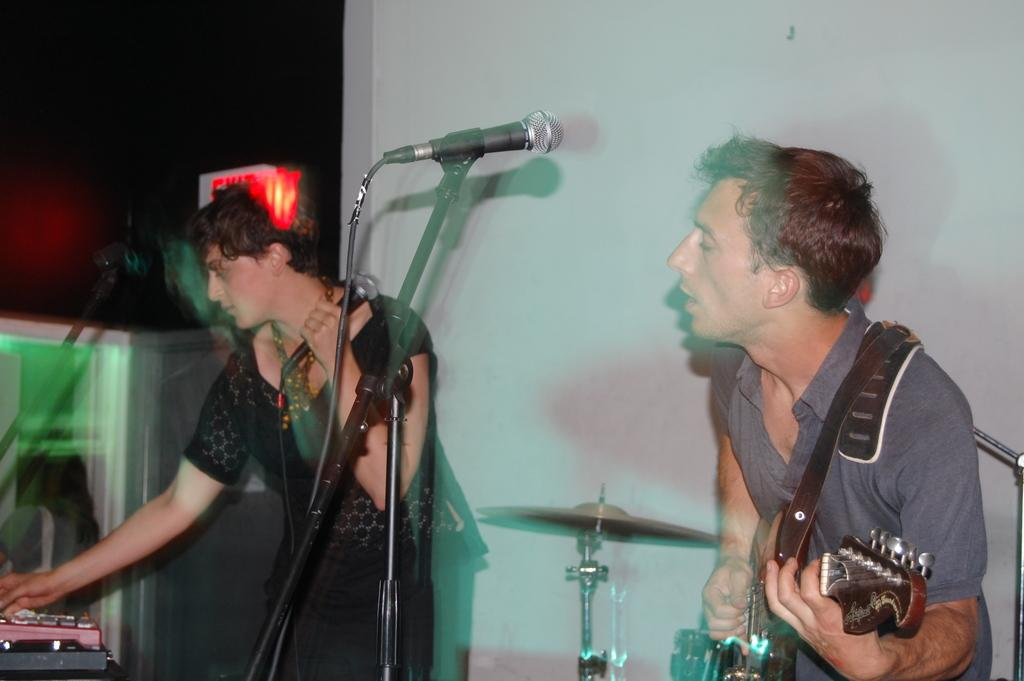How many people are in the image? There are two people in the image. What are the people holding in the image? One person is holding a guitar, and the other person is holding a microphone. What can be inferred about the scene in the image? The image depicts a musical band. What else can be seen in the image besides the people and their instruments? There is a cable wire in the image. Where are the children playing in the image? There are no children present in the image. 